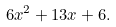<formula> <loc_0><loc_0><loc_500><loc_500>6 x ^ { 2 } + 1 3 x + 6 .</formula> 